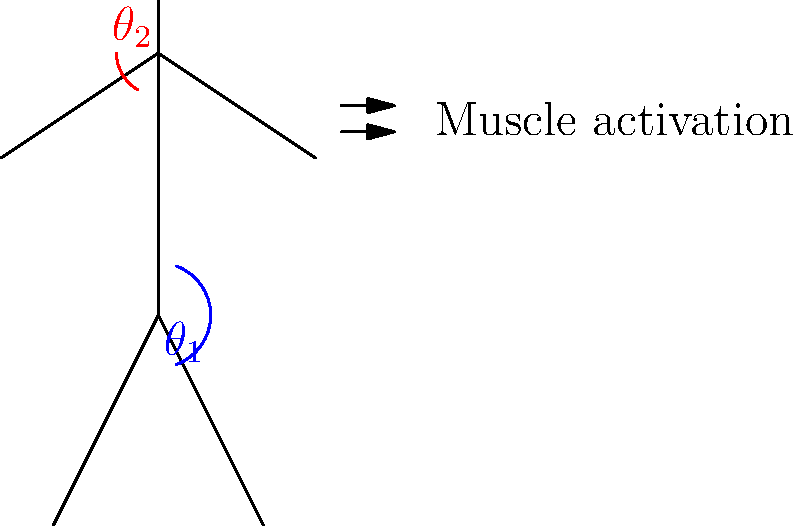During a protest march, a photojournalist observes participants' body postures. If the hip angle ($\theta_1$) is 140° and the shoulder angle ($\theta_2$) is 60°, calculate the total muscle activation level, given that hip muscles contribute 0.8 units per degree and shoulder muscles contribute 1.2 units per degree of joint angle deviation from neutral position (180° for hip, 0° for shoulder). To solve this problem, we need to follow these steps:

1. Calculate the hip angle deviation from neutral:
   Hip deviation = 180° - $\theta_1$ = 180° - 140° = 40°

2. Calculate the shoulder angle deviation from neutral:
   Shoulder deviation = $\theta_2$ - 0° = 60° - 0° = 60°

3. Calculate the muscle activation for hip:
   Hip activation = 40° × 0.8 units/degree = 32 units

4. Calculate the muscle activation for shoulder:
   Shoulder activation = 60° × 1.2 units/degree = 72 units

5. Sum up the total muscle activation:
   Total activation = Hip activation + Shoulder activation
                    = 32 units + 72 units
                    = 104 units

Therefore, the total muscle activation level during the observed posture is 104 units.
Answer: 104 units 